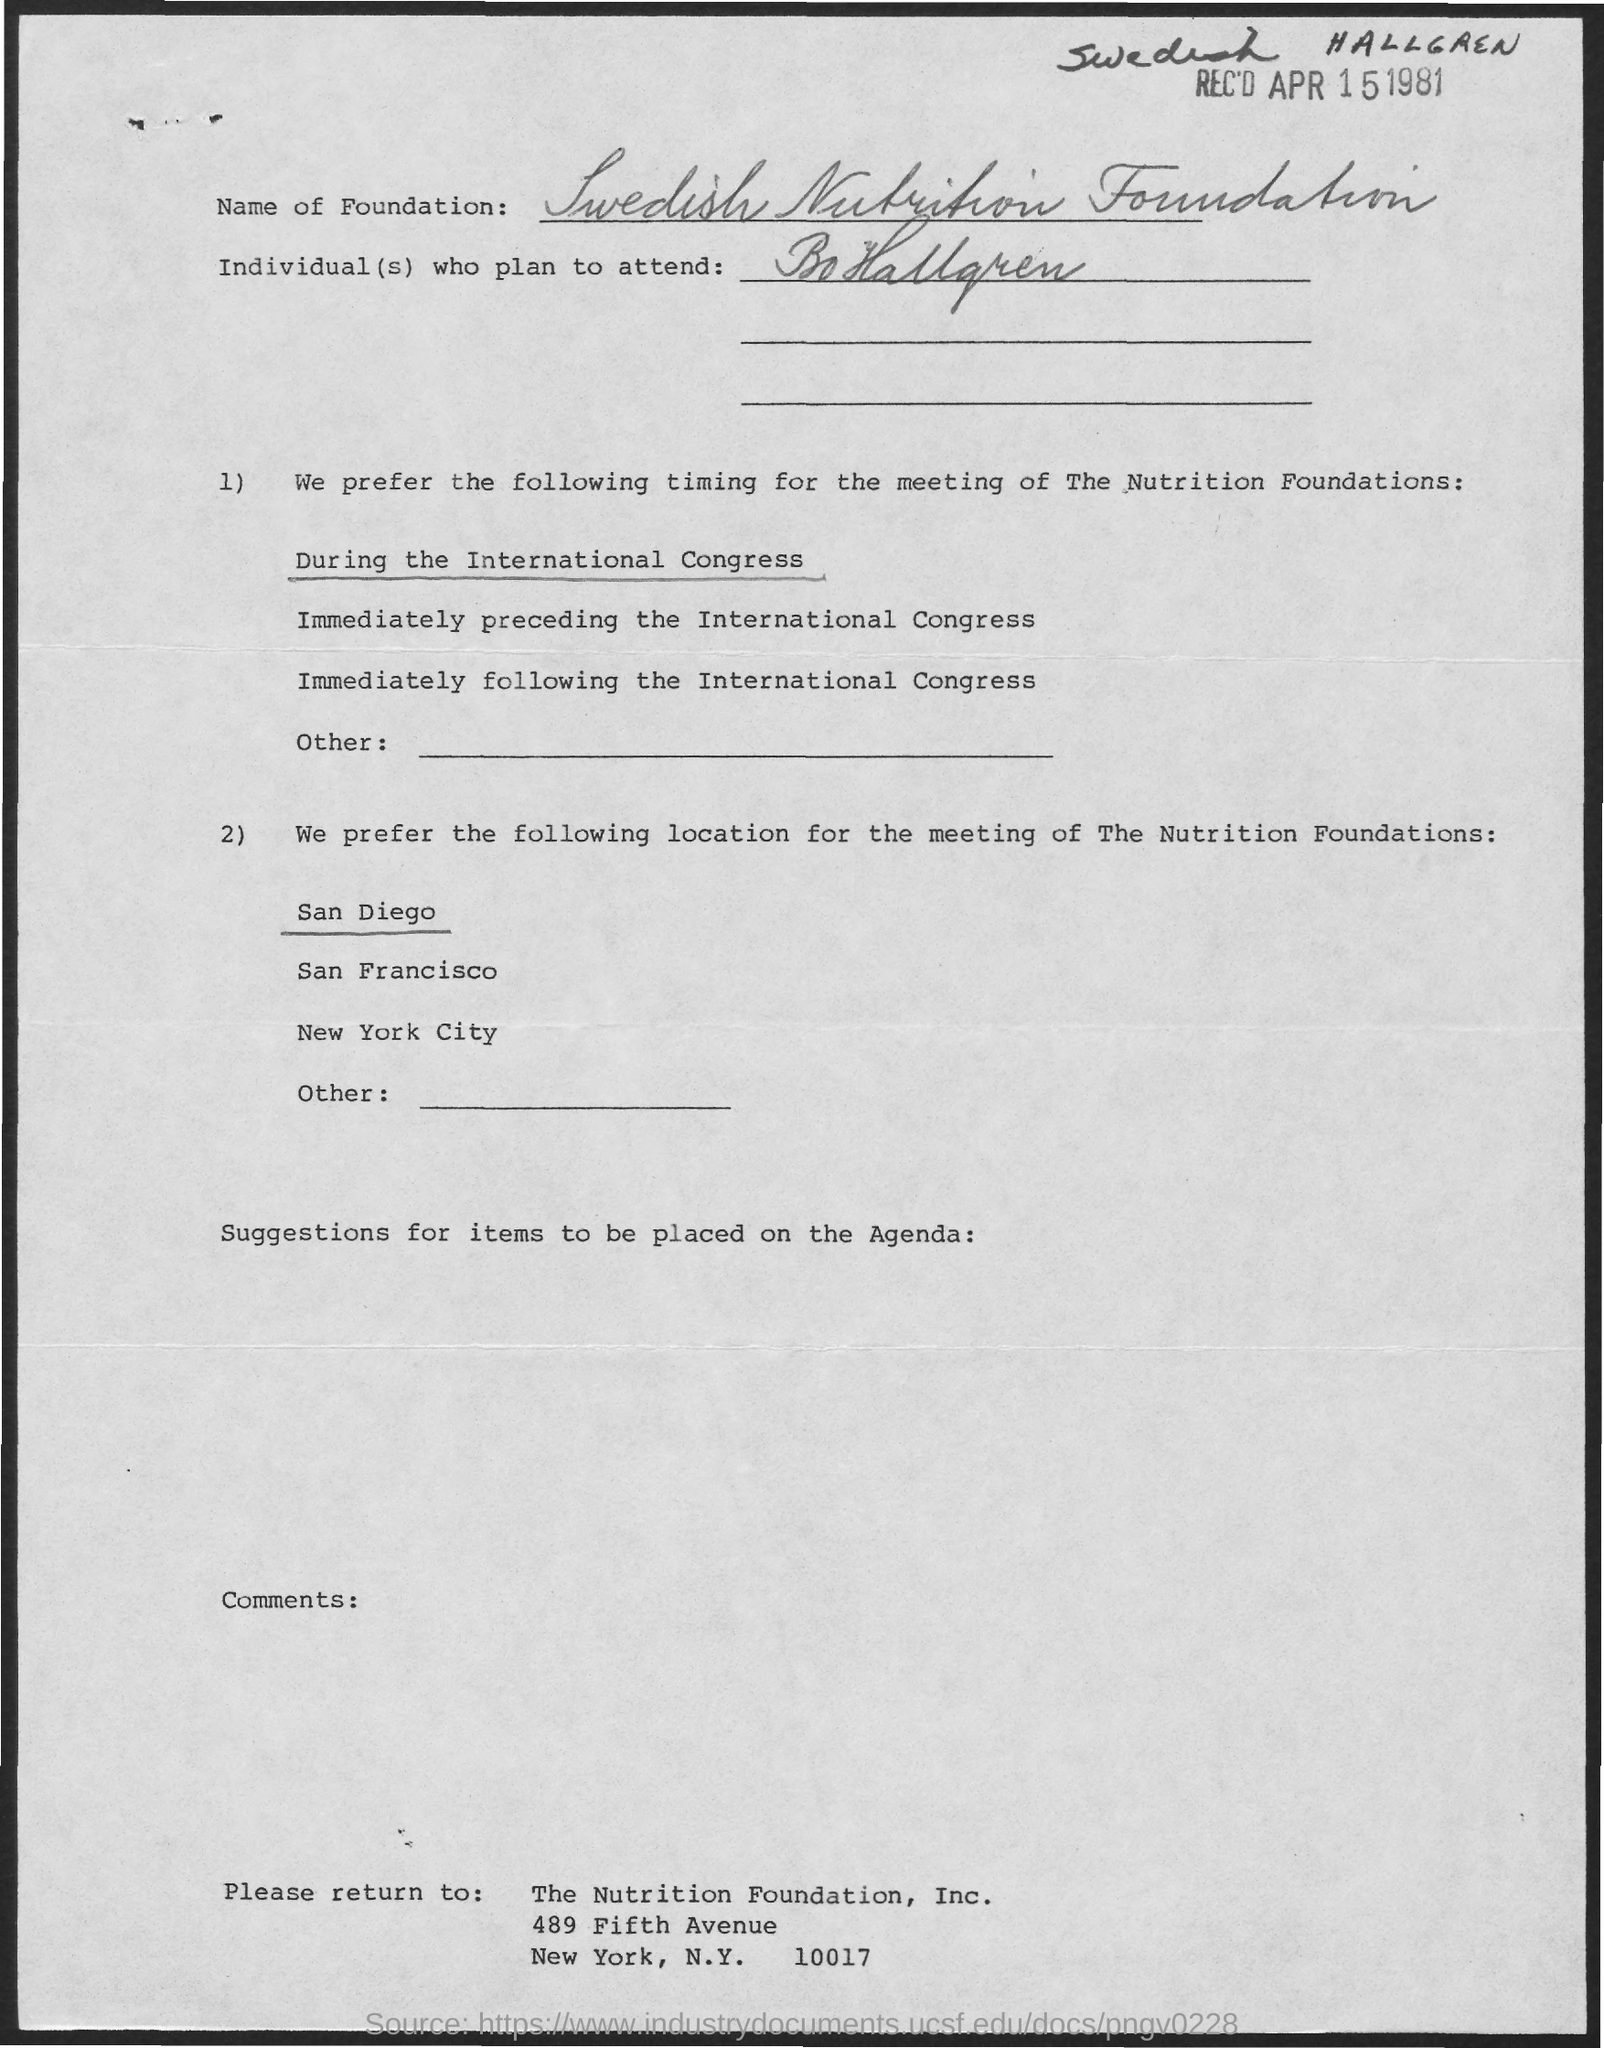What date is it received?
Give a very brief answer. APR 15 1981. What is the Name of the Foundation?
Your answer should be very brief. Swedish Nutrition Foundation. 